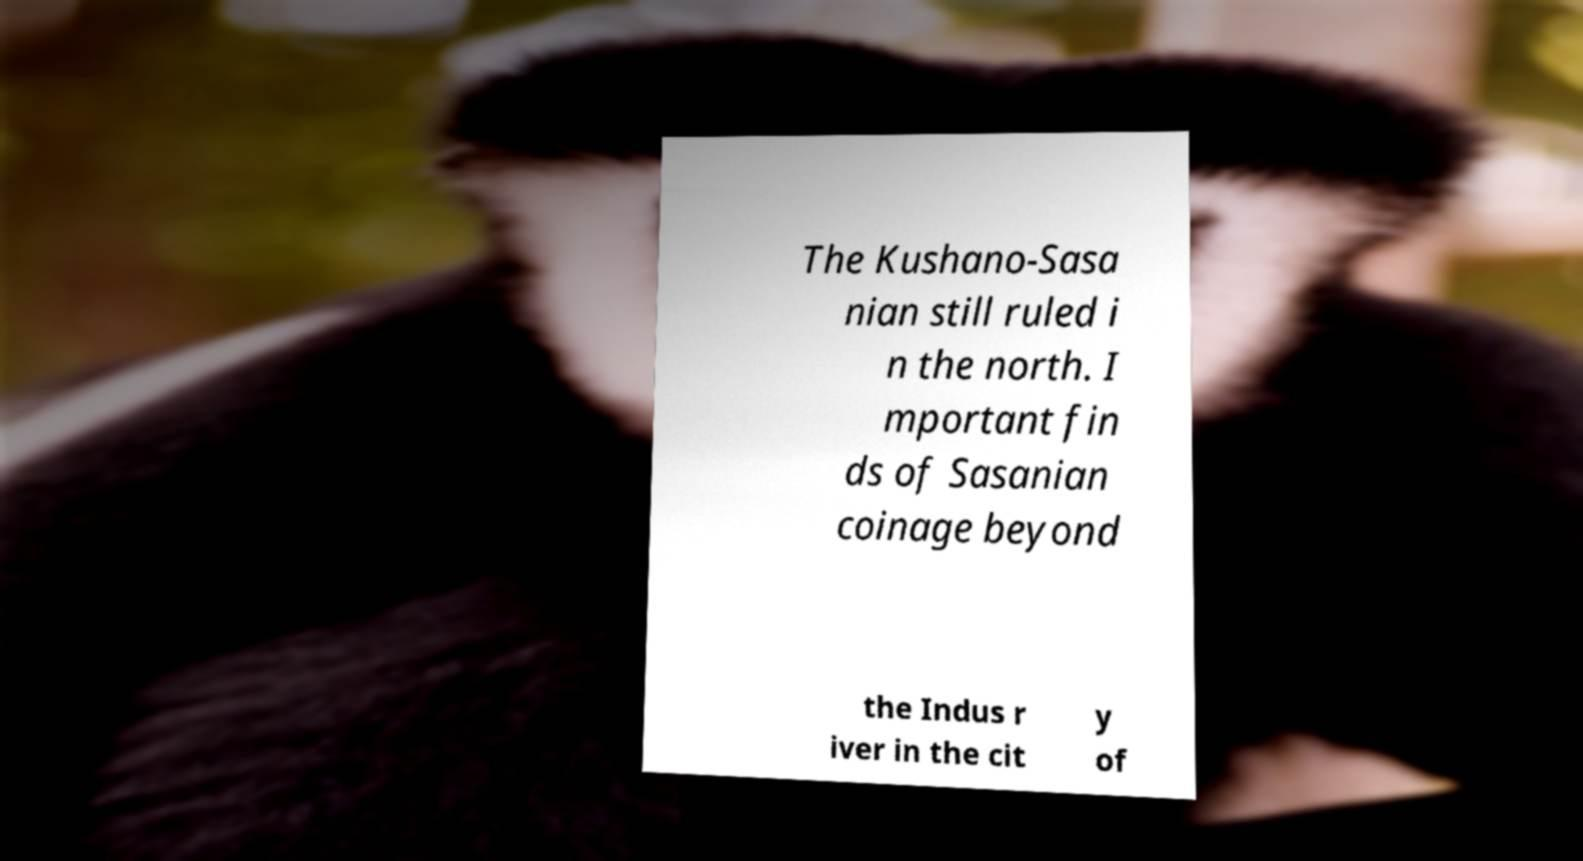What messages or text are displayed in this image? I need them in a readable, typed format. The Kushano-Sasa nian still ruled i n the north. I mportant fin ds of Sasanian coinage beyond the Indus r iver in the cit y of 